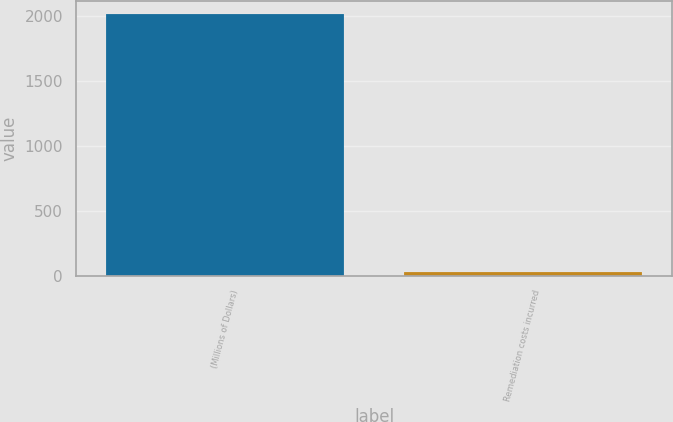Convert chart to OTSL. <chart><loc_0><loc_0><loc_500><loc_500><bar_chart><fcel>(Millions of Dollars)<fcel>Remediation costs incurred<nl><fcel>2018<fcel>25<nl></chart> 